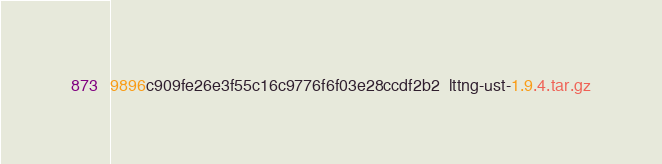Convert code to text. <code><loc_0><loc_0><loc_500><loc_500><_SML_>9896c909fe26e3f55c16c9776f6f03e28ccdf2b2  lttng-ust-1.9.4.tar.gz
</code> 